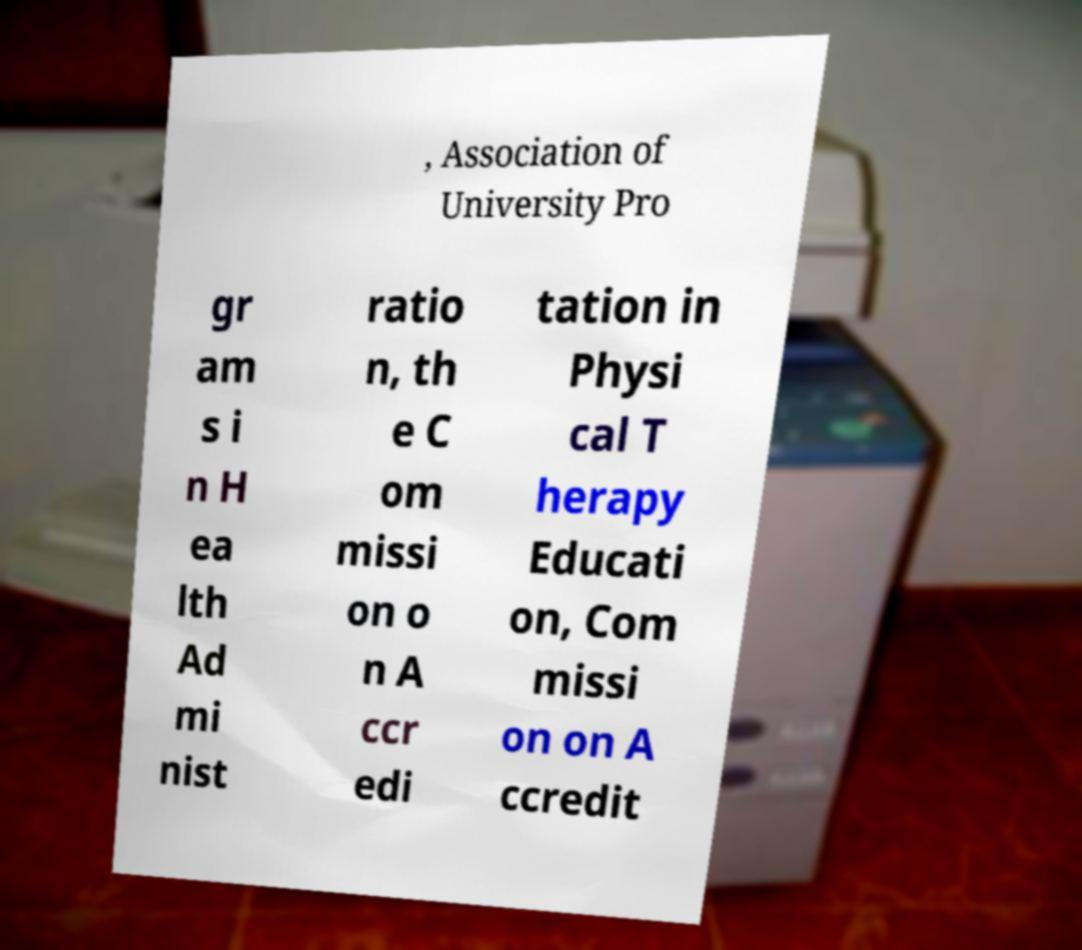Please read and relay the text visible in this image. What does it say? , Association of University Pro gr am s i n H ea lth Ad mi nist ratio n, th e C om missi on o n A ccr edi tation in Physi cal T herapy Educati on, Com missi on on A ccredit 